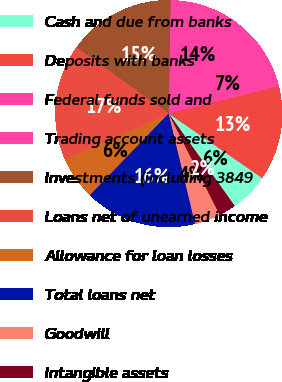Convert chart to OTSL. <chart><loc_0><loc_0><loc_500><loc_500><pie_chart><fcel>Cash and due from banks<fcel>Deposits with banks<fcel>Federal funds sold and<fcel>Trading account assets<fcel>Investments (including 3849<fcel>Loans net of unearned income<fcel>Allowance for loan losses<fcel>Total loans net<fcel>Goodwill<fcel>Intangible assets<nl><fcel>5.52%<fcel>13.5%<fcel>6.75%<fcel>14.11%<fcel>15.34%<fcel>16.56%<fcel>6.14%<fcel>15.95%<fcel>3.68%<fcel>2.46%<nl></chart> 